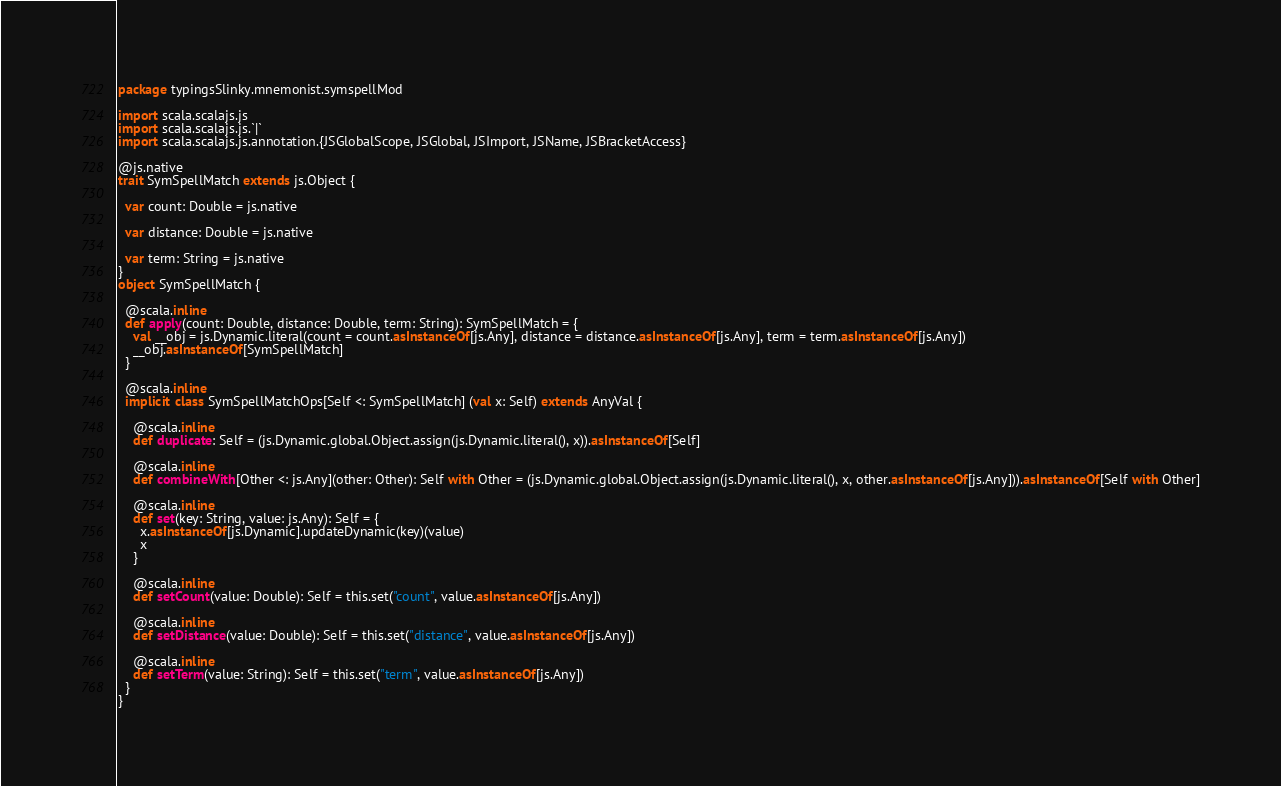<code> <loc_0><loc_0><loc_500><loc_500><_Scala_>package typingsSlinky.mnemonist.symspellMod

import scala.scalajs.js
import scala.scalajs.js.`|`
import scala.scalajs.js.annotation.{JSGlobalScope, JSGlobal, JSImport, JSName, JSBracketAccess}

@js.native
trait SymSpellMatch extends js.Object {
  
  var count: Double = js.native
  
  var distance: Double = js.native
  
  var term: String = js.native
}
object SymSpellMatch {
  
  @scala.inline
  def apply(count: Double, distance: Double, term: String): SymSpellMatch = {
    val __obj = js.Dynamic.literal(count = count.asInstanceOf[js.Any], distance = distance.asInstanceOf[js.Any], term = term.asInstanceOf[js.Any])
    __obj.asInstanceOf[SymSpellMatch]
  }
  
  @scala.inline
  implicit class SymSpellMatchOps[Self <: SymSpellMatch] (val x: Self) extends AnyVal {
    
    @scala.inline
    def duplicate: Self = (js.Dynamic.global.Object.assign(js.Dynamic.literal(), x)).asInstanceOf[Self]
    
    @scala.inline
    def combineWith[Other <: js.Any](other: Other): Self with Other = (js.Dynamic.global.Object.assign(js.Dynamic.literal(), x, other.asInstanceOf[js.Any])).asInstanceOf[Self with Other]
    
    @scala.inline
    def set(key: String, value: js.Any): Self = {
      x.asInstanceOf[js.Dynamic].updateDynamic(key)(value)
      x
    }
    
    @scala.inline
    def setCount(value: Double): Self = this.set("count", value.asInstanceOf[js.Any])
    
    @scala.inline
    def setDistance(value: Double): Self = this.set("distance", value.asInstanceOf[js.Any])
    
    @scala.inline
    def setTerm(value: String): Self = this.set("term", value.asInstanceOf[js.Any])
  }
}
</code> 